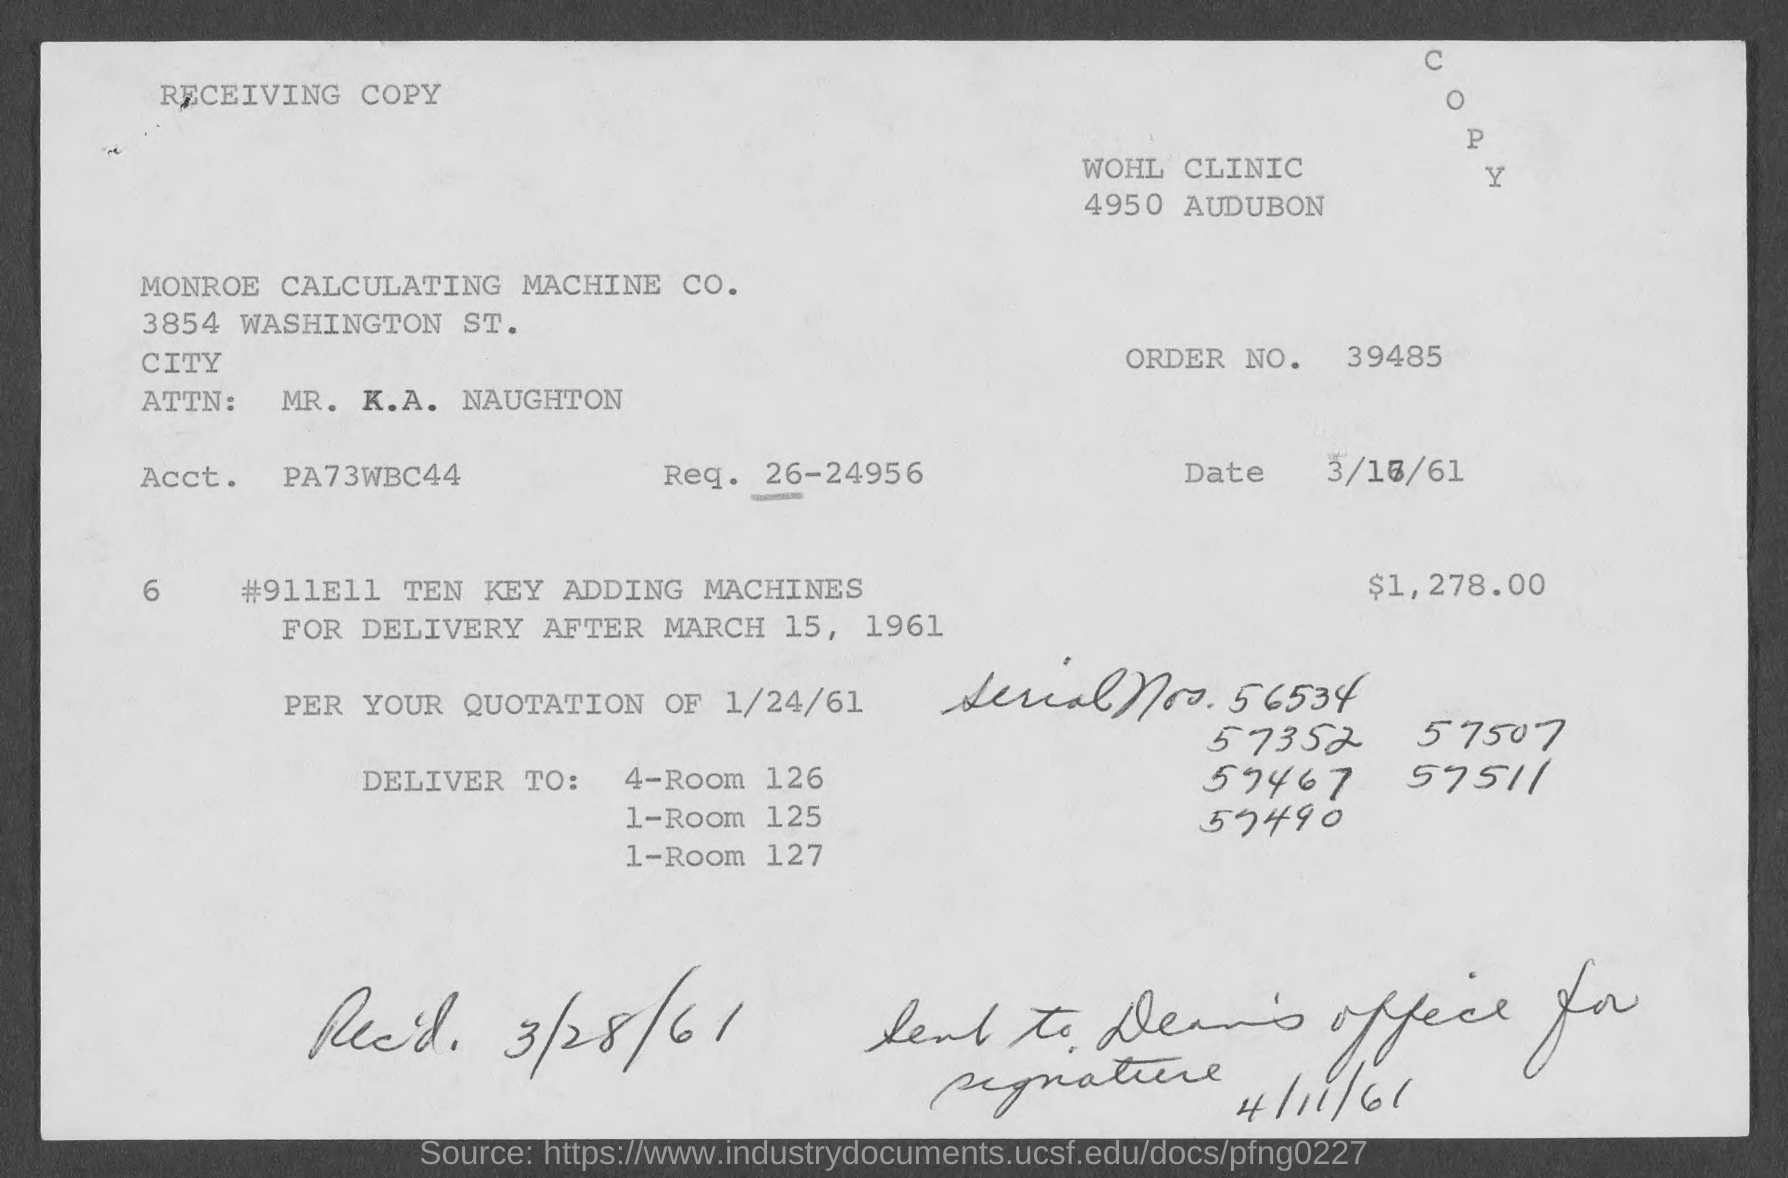Mention a couple of crucial points in this snapshot. The order number mentioned on the given page is 39485. The amount mentioned in the given form is $1,278.00. The required number mentioned in the given form is 26-24956. The date mentioned on the given page is March 28, 1961. The account mentioned in the given form is PA73WBC44... 